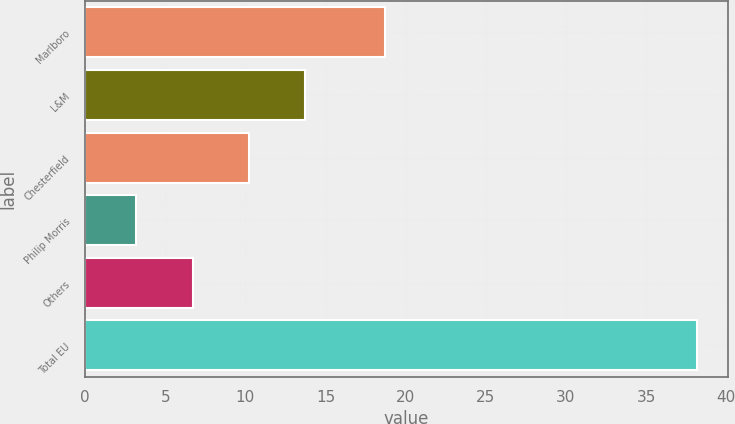Convert chart to OTSL. <chart><loc_0><loc_0><loc_500><loc_500><bar_chart><fcel>Marlboro<fcel>L&M<fcel>Chesterfield<fcel>Philip Morris<fcel>Others<fcel>Total EU<nl><fcel>18.7<fcel>13.7<fcel>10.2<fcel>3.2<fcel>6.7<fcel>38.2<nl></chart> 